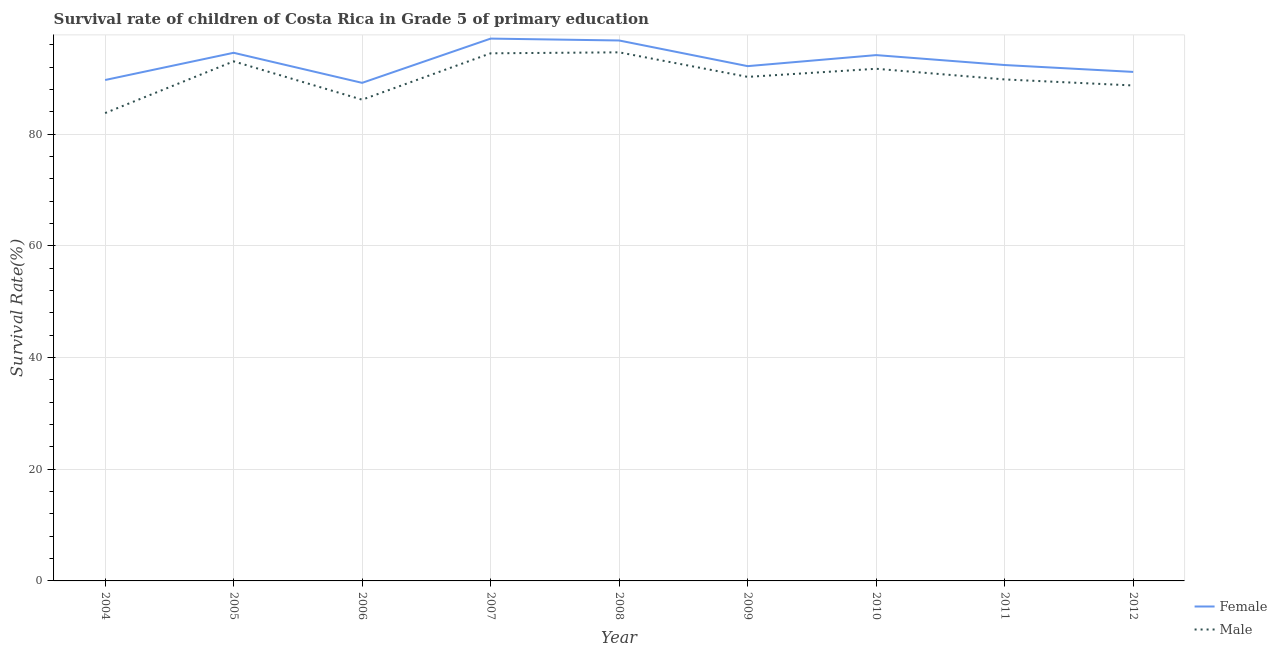How many different coloured lines are there?
Ensure brevity in your answer.  2. What is the survival rate of male students in primary education in 2011?
Provide a succinct answer. 89.78. Across all years, what is the maximum survival rate of female students in primary education?
Provide a succinct answer. 97.09. Across all years, what is the minimum survival rate of male students in primary education?
Offer a terse response. 83.76. In which year was the survival rate of female students in primary education minimum?
Keep it short and to the point. 2006. What is the total survival rate of male students in primary education in the graph?
Offer a very short reply. 812.45. What is the difference between the survival rate of male students in primary education in 2006 and that in 2009?
Offer a terse response. -4.09. What is the difference between the survival rate of male students in primary education in 2005 and the survival rate of female students in primary education in 2012?
Your answer should be compact. 1.89. What is the average survival rate of male students in primary education per year?
Provide a succinct answer. 90.27. In the year 2012, what is the difference between the survival rate of female students in primary education and survival rate of male students in primary education?
Offer a terse response. 2.43. What is the ratio of the survival rate of female students in primary education in 2010 to that in 2012?
Keep it short and to the point. 1.03. Is the survival rate of female students in primary education in 2008 less than that in 2009?
Your answer should be compact. No. What is the difference between the highest and the second highest survival rate of female students in primary education?
Make the answer very short. 0.34. What is the difference between the highest and the lowest survival rate of female students in primary education?
Make the answer very short. 7.92. In how many years, is the survival rate of female students in primary education greater than the average survival rate of female students in primary education taken over all years?
Make the answer very short. 4. Does the survival rate of female students in primary education monotonically increase over the years?
Your response must be concise. No. How many lines are there?
Offer a terse response. 2. What is the difference between two consecutive major ticks on the Y-axis?
Make the answer very short. 20. Are the values on the major ticks of Y-axis written in scientific E-notation?
Provide a succinct answer. No. Does the graph contain grids?
Offer a very short reply. Yes. How many legend labels are there?
Give a very brief answer. 2. What is the title of the graph?
Your answer should be compact. Survival rate of children of Costa Rica in Grade 5 of primary education. What is the label or title of the Y-axis?
Give a very brief answer. Survival Rate(%). What is the Survival Rate(%) in Female in 2004?
Ensure brevity in your answer.  89.68. What is the Survival Rate(%) in Male in 2004?
Offer a terse response. 83.76. What is the Survival Rate(%) in Female in 2005?
Your answer should be compact. 94.55. What is the Survival Rate(%) of Male in 2005?
Your response must be concise. 93.02. What is the Survival Rate(%) of Female in 2006?
Keep it short and to the point. 89.17. What is the Survival Rate(%) of Male in 2006?
Provide a succinct answer. 86.16. What is the Survival Rate(%) in Female in 2007?
Your answer should be compact. 97.09. What is the Survival Rate(%) of Male in 2007?
Ensure brevity in your answer.  94.46. What is the Survival Rate(%) in Female in 2008?
Provide a short and direct response. 96.76. What is the Survival Rate(%) of Male in 2008?
Keep it short and to the point. 94.63. What is the Survival Rate(%) in Female in 2009?
Your answer should be compact. 92.16. What is the Survival Rate(%) in Male in 2009?
Your answer should be very brief. 90.24. What is the Survival Rate(%) in Female in 2010?
Give a very brief answer. 94.14. What is the Survival Rate(%) in Male in 2010?
Give a very brief answer. 91.69. What is the Survival Rate(%) of Female in 2011?
Ensure brevity in your answer.  92.36. What is the Survival Rate(%) of Male in 2011?
Offer a terse response. 89.78. What is the Survival Rate(%) of Female in 2012?
Ensure brevity in your answer.  91.13. What is the Survival Rate(%) in Male in 2012?
Provide a succinct answer. 88.7. Across all years, what is the maximum Survival Rate(%) in Female?
Your response must be concise. 97.09. Across all years, what is the maximum Survival Rate(%) in Male?
Provide a short and direct response. 94.63. Across all years, what is the minimum Survival Rate(%) of Female?
Keep it short and to the point. 89.17. Across all years, what is the minimum Survival Rate(%) in Male?
Your answer should be compact. 83.76. What is the total Survival Rate(%) of Female in the graph?
Make the answer very short. 837.05. What is the total Survival Rate(%) of Male in the graph?
Provide a short and direct response. 812.45. What is the difference between the Survival Rate(%) in Female in 2004 and that in 2005?
Give a very brief answer. -4.87. What is the difference between the Survival Rate(%) in Male in 2004 and that in 2005?
Provide a succinct answer. -9.26. What is the difference between the Survival Rate(%) in Female in 2004 and that in 2006?
Give a very brief answer. 0.51. What is the difference between the Survival Rate(%) of Male in 2004 and that in 2006?
Give a very brief answer. -2.39. What is the difference between the Survival Rate(%) in Female in 2004 and that in 2007?
Your response must be concise. -7.41. What is the difference between the Survival Rate(%) in Male in 2004 and that in 2007?
Provide a succinct answer. -10.7. What is the difference between the Survival Rate(%) of Female in 2004 and that in 2008?
Offer a very short reply. -7.08. What is the difference between the Survival Rate(%) in Male in 2004 and that in 2008?
Keep it short and to the point. -10.87. What is the difference between the Survival Rate(%) in Female in 2004 and that in 2009?
Your answer should be very brief. -2.48. What is the difference between the Survival Rate(%) of Male in 2004 and that in 2009?
Provide a succinct answer. -6.48. What is the difference between the Survival Rate(%) in Female in 2004 and that in 2010?
Give a very brief answer. -4.46. What is the difference between the Survival Rate(%) in Male in 2004 and that in 2010?
Provide a short and direct response. -7.93. What is the difference between the Survival Rate(%) of Female in 2004 and that in 2011?
Your response must be concise. -2.68. What is the difference between the Survival Rate(%) of Male in 2004 and that in 2011?
Provide a succinct answer. -6.02. What is the difference between the Survival Rate(%) of Female in 2004 and that in 2012?
Ensure brevity in your answer.  -1.45. What is the difference between the Survival Rate(%) in Male in 2004 and that in 2012?
Keep it short and to the point. -4.94. What is the difference between the Survival Rate(%) of Female in 2005 and that in 2006?
Your response must be concise. 5.38. What is the difference between the Survival Rate(%) in Male in 2005 and that in 2006?
Give a very brief answer. 6.87. What is the difference between the Survival Rate(%) of Female in 2005 and that in 2007?
Your answer should be compact. -2.54. What is the difference between the Survival Rate(%) of Male in 2005 and that in 2007?
Offer a terse response. -1.44. What is the difference between the Survival Rate(%) of Female in 2005 and that in 2008?
Your response must be concise. -2.2. What is the difference between the Survival Rate(%) in Male in 2005 and that in 2008?
Your answer should be very brief. -1.61. What is the difference between the Survival Rate(%) of Female in 2005 and that in 2009?
Ensure brevity in your answer.  2.39. What is the difference between the Survival Rate(%) in Male in 2005 and that in 2009?
Offer a very short reply. 2.78. What is the difference between the Survival Rate(%) of Female in 2005 and that in 2010?
Make the answer very short. 0.41. What is the difference between the Survival Rate(%) in Male in 2005 and that in 2010?
Your answer should be very brief. 1.33. What is the difference between the Survival Rate(%) of Female in 2005 and that in 2011?
Your answer should be very brief. 2.19. What is the difference between the Survival Rate(%) of Male in 2005 and that in 2011?
Your answer should be very brief. 3.24. What is the difference between the Survival Rate(%) of Female in 2005 and that in 2012?
Provide a succinct answer. 3.42. What is the difference between the Survival Rate(%) of Male in 2005 and that in 2012?
Your response must be concise. 4.32. What is the difference between the Survival Rate(%) in Female in 2006 and that in 2007?
Provide a short and direct response. -7.92. What is the difference between the Survival Rate(%) of Male in 2006 and that in 2007?
Ensure brevity in your answer.  -8.31. What is the difference between the Survival Rate(%) in Female in 2006 and that in 2008?
Offer a terse response. -7.59. What is the difference between the Survival Rate(%) of Male in 2006 and that in 2008?
Keep it short and to the point. -8.48. What is the difference between the Survival Rate(%) in Female in 2006 and that in 2009?
Your response must be concise. -2.99. What is the difference between the Survival Rate(%) of Male in 2006 and that in 2009?
Provide a short and direct response. -4.09. What is the difference between the Survival Rate(%) in Female in 2006 and that in 2010?
Offer a terse response. -4.97. What is the difference between the Survival Rate(%) of Male in 2006 and that in 2010?
Offer a terse response. -5.54. What is the difference between the Survival Rate(%) in Female in 2006 and that in 2011?
Give a very brief answer. -3.19. What is the difference between the Survival Rate(%) of Male in 2006 and that in 2011?
Ensure brevity in your answer.  -3.63. What is the difference between the Survival Rate(%) in Female in 2006 and that in 2012?
Make the answer very short. -1.96. What is the difference between the Survival Rate(%) of Male in 2006 and that in 2012?
Provide a short and direct response. -2.55. What is the difference between the Survival Rate(%) of Female in 2007 and that in 2008?
Ensure brevity in your answer.  0.34. What is the difference between the Survival Rate(%) in Male in 2007 and that in 2008?
Keep it short and to the point. -0.17. What is the difference between the Survival Rate(%) in Female in 2007 and that in 2009?
Give a very brief answer. 4.93. What is the difference between the Survival Rate(%) in Male in 2007 and that in 2009?
Ensure brevity in your answer.  4.22. What is the difference between the Survival Rate(%) in Female in 2007 and that in 2010?
Your answer should be compact. 2.95. What is the difference between the Survival Rate(%) of Male in 2007 and that in 2010?
Make the answer very short. 2.77. What is the difference between the Survival Rate(%) of Female in 2007 and that in 2011?
Your response must be concise. 4.73. What is the difference between the Survival Rate(%) of Male in 2007 and that in 2011?
Your answer should be compact. 4.68. What is the difference between the Survival Rate(%) of Female in 2007 and that in 2012?
Ensure brevity in your answer.  5.96. What is the difference between the Survival Rate(%) of Male in 2007 and that in 2012?
Ensure brevity in your answer.  5.76. What is the difference between the Survival Rate(%) in Female in 2008 and that in 2009?
Give a very brief answer. 4.59. What is the difference between the Survival Rate(%) in Male in 2008 and that in 2009?
Make the answer very short. 4.39. What is the difference between the Survival Rate(%) in Female in 2008 and that in 2010?
Offer a very short reply. 2.62. What is the difference between the Survival Rate(%) of Male in 2008 and that in 2010?
Make the answer very short. 2.94. What is the difference between the Survival Rate(%) of Female in 2008 and that in 2011?
Ensure brevity in your answer.  4.4. What is the difference between the Survival Rate(%) of Male in 2008 and that in 2011?
Your answer should be very brief. 4.85. What is the difference between the Survival Rate(%) in Female in 2008 and that in 2012?
Provide a succinct answer. 5.63. What is the difference between the Survival Rate(%) in Male in 2008 and that in 2012?
Offer a terse response. 5.93. What is the difference between the Survival Rate(%) in Female in 2009 and that in 2010?
Provide a succinct answer. -1.98. What is the difference between the Survival Rate(%) of Male in 2009 and that in 2010?
Offer a terse response. -1.45. What is the difference between the Survival Rate(%) of Female in 2009 and that in 2011?
Provide a short and direct response. -0.2. What is the difference between the Survival Rate(%) of Male in 2009 and that in 2011?
Your answer should be compact. 0.46. What is the difference between the Survival Rate(%) in Female in 2009 and that in 2012?
Your answer should be compact. 1.03. What is the difference between the Survival Rate(%) of Male in 2009 and that in 2012?
Your answer should be very brief. 1.54. What is the difference between the Survival Rate(%) of Female in 2010 and that in 2011?
Your response must be concise. 1.78. What is the difference between the Survival Rate(%) in Male in 2010 and that in 2011?
Your answer should be very brief. 1.91. What is the difference between the Survival Rate(%) in Female in 2010 and that in 2012?
Give a very brief answer. 3.01. What is the difference between the Survival Rate(%) of Male in 2010 and that in 2012?
Keep it short and to the point. 2.99. What is the difference between the Survival Rate(%) of Female in 2011 and that in 2012?
Provide a short and direct response. 1.23. What is the difference between the Survival Rate(%) in Male in 2011 and that in 2012?
Offer a terse response. 1.08. What is the difference between the Survival Rate(%) in Female in 2004 and the Survival Rate(%) in Male in 2005?
Your answer should be very brief. -3.34. What is the difference between the Survival Rate(%) in Female in 2004 and the Survival Rate(%) in Male in 2006?
Provide a short and direct response. 3.53. What is the difference between the Survival Rate(%) in Female in 2004 and the Survival Rate(%) in Male in 2007?
Offer a terse response. -4.78. What is the difference between the Survival Rate(%) in Female in 2004 and the Survival Rate(%) in Male in 2008?
Offer a terse response. -4.95. What is the difference between the Survival Rate(%) in Female in 2004 and the Survival Rate(%) in Male in 2009?
Provide a succinct answer. -0.56. What is the difference between the Survival Rate(%) of Female in 2004 and the Survival Rate(%) of Male in 2010?
Give a very brief answer. -2.01. What is the difference between the Survival Rate(%) in Female in 2004 and the Survival Rate(%) in Male in 2011?
Provide a succinct answer. -0.1. What is the difference between the Survival Rate(%) of Female in 2004 and the Survival Rate(%) of Male in 2012?
Your answer should be very brief. 0.98. What is the difference between the Survival Rate(%) of Female in 2005 and the Survival Rate(%) of Male in 2006?
Make the answer very short. 8.4. What is the difference between the Survival Rate(%) of Female in 2005 and the Survival Rate(%) of Male in 2007?
Your answer should be compact. 0.09. What is the difference between the Survival Rate(%) of Female in 2005 and the Survival Rate(%) of Male in 2008?
Your response must be concise. -0.08. What is the difference between the Survival Rate(%) in Female in 2005 and the Survival Rate(%) in Male in 2009?
Make the answer very short. 4.31. What is the difference between the Survival Rate(%) of Female in 2005 and the Survival Rate(%) of Male in 2010?
Keep it short and to the point. 2.86. What is the difference between the Survival Rate(%) in Female in 2005 and the Survival Rate(%) in Male in 2011?
Keep it short and to the point. 4.77. What is the difference between the Survival Rate(%) in Female in 2005 and the Survival Rate(%) in Male in 2012?
Provide a short and direct response. 5.85. What is the difference between the Survival Rate(%) in Female in 2006 and the Survival Rate(%) in Male in 2007?
Offer a terse response. -5.29. What is the difference between the Survival Rate(%) of Female in 2006 and the Survival Rate(%) of Male in 2008?
Offer a terse response. -5.46. What is the difference between the Survival Rate(%) of Female in 2006 and the Survival Rate(%) of Male in 2009?
Your response must be concise. -1.07. What is the difference between the Survival Rate(%) in Female in 2006 and the Survival Rate(%) in Male in 2010?
Offer a terse response. -2.52. What is the difference between the Survival Rate(%) in Female in 2006 and the Survival Rate(%) in Male in 2011?
Your answer should be very brief. -0.61. What is the difference between the Survival Rate(%) in Female in 2006 and the Survival Rate(%) in Male in 2012?
Keep it short and to the point. 0.47. What is the difference between the Survival Rate(%) in Female in 2007 and the Survival Rate(%) in Male in 2008?
Your answer should be compact. 2.46. What is the difference between the Survival Rate(%) of Female in 2007 and the Survival Rate(%) of Male in 2009?
Ensure brevity in your answer.  6.85. What is the difference between the Survival Rate(%) in Female in 2007 and the Survival Rate(%) in Male in 2010?
Your answer should be very brief. 5.4. What is the difference between the Survival Rate(%) in Female in 2007 and the Survival Rate(%) in Male in 2011?
Your answer should be very brief. 7.31. What is the difference between the Survival Rate(%) of Female in 2007 and the Survival Rate(%) of Male in 2012?
Your answer should be very brief. 8.39. What is the difference between the Survival Rate(%) of Female in 2008 and the Survival Rate(%) of Male in 2009?
Provide a succinct answer. 6.52. What is the difference between the Survival Rate(%) of Female in 2008 and the Survival Rate(%) of Male in 2010?
Make the answer very short. 5.07. What is the difference between the Survival Rate(%) of Female in 2008 and the Survival Rate(%) of Male in 2011?
Keep it short and to the point. 6.97. What is the difference between the Survival Rate(%) of Female in 2008 and the Survival Rate(%) of Male in 2012?
Ensure brevity in your answer.  8.05. What is the difference between the Survival Rate(%) of Female in 2009 and the Survival Rate(%) of Male in 2010?
Offer a terse response. 0.47. What is the difference between the Survival Rate(%) of Female in 2009 and the Survival Rate(%) of Male in 2011?
Provide a short and direct response. 2.38. What is the difference between the Survival Rate(%) in Female in 2009 and the Survival Rate(%) in Male in 2012?
Offer a very short reply. 3.46. What is the difference between the Survival Rate(%) of Female in 2010 and the Survival Rate(%) of Male in 2011?
Give a very brief answer. 4.36. What is the difference between the Survival Rate(%) in Female in 2010 and the Survival Rate(%) in Male in 2012?
Provide a succinct answer. 5.44. What is the difference between the Survival Rate(%) in Female in 2011 and the Survival Rate(%) in Male in 2012?
Your response must be concise. 3.66. What is the average Survival Rate(%) in Female per year?
Keep it short and to the point. 93.01. What is the average Survival Rate(%) in Male per year?
Ensure brevity in your answer.  90.27. In the year 2004, what is the difference between the Survival Rate(%) in Female and Survival Rate(%) in Male?
Provide a succinct answer. 5.92. In the year 2005, what is the difference between the Survival Rate(%) in Female and Survival Rate(%) in Male?
Make the answer very short. 1.53. In the year 2006, what is the difference between the Survival Rate(%) in Female and Survival Rate(%) in Male?
Provide a succinct answer. 3.01. In the year 2007, what is the difference between the Survival Rate(%) of Female and Survival Rate(%) of Male?
Your response must be concise. 2.63. In the year 2008, what is the difference between the Survival Rate(%) in Female and Survival Rate(%) in Male?
Give a very brief answer. 2.12. In the year 2009, what is the difference between the Survival Rate(%) of Female and Survival Rate(%) of Male?
Provide a succinct answer. 1.92. In the year 2010, what is the difference between the Survival Rate(%) in Female and Survival Rate(%) in Male?
Provide a succinct answer. 2.45. In the year 2011, what is the difference between the Survival Rate(%) in Female and Survival Rate(%) in Male?
Make the answer very short. 2.58. In the year 2012, what is the difference between the Survival Rate(%) of Female and Survival Rate(%) of Male?
Ensure brevity in your answer.  2.43. What is the ratio of the Survival Rate(%) of Female in 2004 to that in 2005?
Make the answer very short. 0.95. What is the ratio of the Survival Rate(%) in Male in 2004 to that in 2005?
Ensure brevity in your answer.  0.9. What is the ratio of the Survival Rate(%) in Female in 2004 to that in 2006?
Ensure brevity in your answer.  1.01. What is the ratio of the Survival Rate(%) of Male in 2004 to that in 2006?
Provide a short and direct response. 0.97. What is the ratio of the Survival Rate(%) in Female in 2004 to that in 2007?
Your response must be concise. 0.92. What is the ratio of the Survival Rate(%) in Male in 2004 to that in 2007?
Provide a succinct answer. 0.89. What is the ratio of the Survival Rate(%) of Female in 2004 to that in 2008?
Keep it short and to the point. 0.93. What is the ratio of the Survival Rate(%) in Male in 2004 to that in 2008?
Keep it short and to the point. 0.89. What is the ratio of the Survival Rate(%) of Female in 2004 to that in 2009?
Provide a succinct answer. 0.97. What is the ratio of the Survival Rate(%) in Male in 2004 to that in 2009?
Provide a short and direct response. 0.93. What is the ratio of the Survival Rate(%) of Female in 2004 to that in 2010?
Your answer should be compact. 0.95. What is the ratio of the Survival Rate(%) of Male in 2004 to that in 2010?
Provide a succinct answer. 0.91. What is the ratio of the Survival Rate(%) of Male in 2004 to that in 2011?
Your answer should be very brief. 0.93. What is the ratio of the Survival Rate(%) in Female in 2004 to that in 2012?
Give a very brief answer. 0.98. What is the ratio of the Survival Rate(%) in Male in 2004 to that in 2012?
Ensure brevity in your answer.  0.94. What is the ratio of the Survival Rate(%) of Female in 2005 to that in 2006?
Give a very brief answer. 1.06. What is the ratio of the Survival Rate(%) of Male in 2005 to that in 2006?
Your response must be concise. 1.08. What is the ratio of the Survival Rate(%) in Female in 2005 to that in 2007?
Offer a very short reply. 0.97. What is the ratio of the Survival Rate(%) of Female in 2005 to that in 2008?
Your answer should be compact. 0.98. What is the ratio of the Survival Rate(%) in Male in 2005 to that in 2008?
Offer a terse response. 0.98. What is the ratio of the Survival Rate(%) of Female in 2005 to that in 2009?
Provide a succinct answer. 1.03. What is the ratio of the Survival Rate(%) of Male in 2005 to that in 2009?
Keep it short and to the point. 1.03. What is the ratio of the Survival Rate(%) of Female in 2005 to that in 2010?
Ensure brevity in your answer.  1. What is the ratio of the Survival Rate(%) in Male in 2005 to that in 2010?
Make the answer very short. 1.01. What is the ratio of the Survival Rate(%) of Female in 2005 to that in 2011?
Provide a succinct answer. 1.02. What is the ratio of the Survival Rate(%) of Male in 2005 to that in 2011?
Your answer should be very brief. 1.04. What is the ratio of the Survival Rate(%) of Female in 2005 to that in 2012?
Your answer should be compact. 1.04. What is the ratio of the Survival Rate(%) of Male in 2005 to that in 2012?
Your response must be concise. 1.05. What is the ratio of the Survival Rate(%) in Female in 2006 to that in 2007?
Make the answer very short. 0.92. What is the ratio of the Survival Rate(%) in Male in 2006 to that in 2007?
Provide a short and direct response. 0.91. What is the ratio of the Survival Rate(%) in Female in 2006 to that in 2008?
Keep it short and to the point. 0.92. What is the ratio of the Survival Rate(%) of Male in 2006 to that in 2008?
Your answer should be very brief. 0.91. What is the ratio of the Survival Rate(%) in Female in 2006 to that in 2009?
Provide a succinct answer. 0.97. What is the ratio of the Survival Rate(%) in Male in 2006 to that in 2009?
Ensure brevity in your answer.  0.95. What is the ratio of the Survival Rate(%) of Female in 2006 to that in 2010?
Give a very brief answer. 0.95. What is the ratio of the Survival Rate(%) in Male in 2006 to that in 2010?
Make the answer very short. 0.94. What is the ratio of the Survival Rate(%) in Female in 2006 to that in 2011?
Your response must be concise. 0.97. What is the ratio of the Survival Rate(%) of Male in 2006 to that in 2011?
Give a very brief answer. 0.96. What is the ratio of the Survival Rate(%) of Female in 2006 to that in 2012?
Make the answer very short. 0.98. What is the ratio of the Survival Rate(%) in Male in 2006 to that in 2012?
Provide a succinct answer. 0.97. What is the ratio of the Survival Rate(%) in Male in 2007 to that in 2008?
Offer a very short reply. 1. What is the ratio of the Survival Rate(%) of Female in 2007 to that in 2009?
Keep it short and to the point. 1.05. What is the ratio of the Survival Rate(%) in Male in 2007 to that in 2009?
Provide a short and direct response. 1.05. What is the ratio of the Survival Rate(%) in Female in 2007 to that in 2010?
Offer a very short reply. 1.03. What is the ratio of the Survival Rate(%) in Male in 2007 to that in 2010?
Ensure brevity in your answer.  1.03. What is the ratio of the Survival Rate(%) in Female in 2007 to that in 2011?
Your answer should be compact. 1.05. What is the ratio of the Survival Rate(%) in Male in 2007 to that in 2011?
Ensure brevity in your answer.  1.05. What is the ratio of the Survival Rate(%) in Female in 2007 to that in 2012?
Make the answer very short. 1.07. What is the ratio of the Survival Rate(%) in Male in 2007 to that in 2012?
Provide a succinct answer. 1.06. What is the ratio of the Survival Rate(%) of Female in 2008 to that in 2009?
Your answer should be very brief. 1.05. What is the ratio of the Survival Rate(%) in Male in 2008 to that in 2009?
Provide a short and direct response. 1.05. What is the ratio of the Survival Rate(%) in Female in 2008 to that in 2010?
Provide a succinct answer. 1.03. What is the ratio of the Survival Rate(%) in Male in 2008 to that in 2010?
Offer a very short reply. 1.03. What is the ratio of the Survival Rate(%) of Female in 2008 to that in 2011?
Offer a terse response. 1.05. What is the ratio of the Survival Rate(%) of Male in 2008 to that in 2011?
Give a very brief answer. 1.05. What is the ratio of the Survival Rate(%) in Female in 2008 to that in 2012?
Provide a short and direct response. 1.06. What is the ratio of the Survival Rate(%) in Male in 2008 to that in 2012?
Ensure brevity in your answer.  1.07. What is the ratio of the Survival Rate(%) in Female in 2009 to that in 2010?
Provide a short and direct response. 0.98. What is the ratio of the Survival Rate(%) in Male in 2009 to that in 2010?
Make the answer very short. 0.98. What is the ratio of the Survival Rate(%) of Female in 2009 to that in 2011?
Make the answer very short. 1. What is the ratio of the Survival Rate(%) in Male in 2009 to that in 2011?
Your answer should be compact. 1.01. What is the ratio of the Survival Rate(%) in Female in 2009 to that in 2012?
Offer a terse response. 1.01. What is the ratio of the Survival Rate(%) in Male in 2009 to that in 2012?
Ensure brevity in your answer.  1.02. What is the ratio of the Survival Rate(%) in Female in 2010 to that in 2011?
Your response must be concise. 1.02. What is the ratio of the Survival Rate(%) of Male in 2010 to that in 2011?
Keep it short and to the point. 1.02. What is the ratio of the Survival Rate(%) of Female in 2010 to that in 2012?
Your answer should be very brief. 1.03. What is the ratio of the Survival Rate(%) in Male in 2010 to that in 2012?
Keep it short and to the point. 1.03. What is the ratio of the Survival Rate(%) of Female in 2011 to that in 2012?
Provide a short and direct response. 1.01. What is the ratio of the Survival Rate(%) of Male in 2011 to that in 2012?
Your answer should be very brief. 1.01. What is the difference between the highest and the second highest Survival Rate(%) in Female?
Offer a terse response. 0.34. What is the difference between the highest and the second highest Survival Rate(%) of Male?
Offer a very short reply. 0.17. What is the difference between the highest and the lowest Survival Rate(%) in Female?
Your answer should be compact. 7.92. What is the difference between the highest and the lowest Survival Rate(%) of Male?
Your answer should be compact. 10.87. 